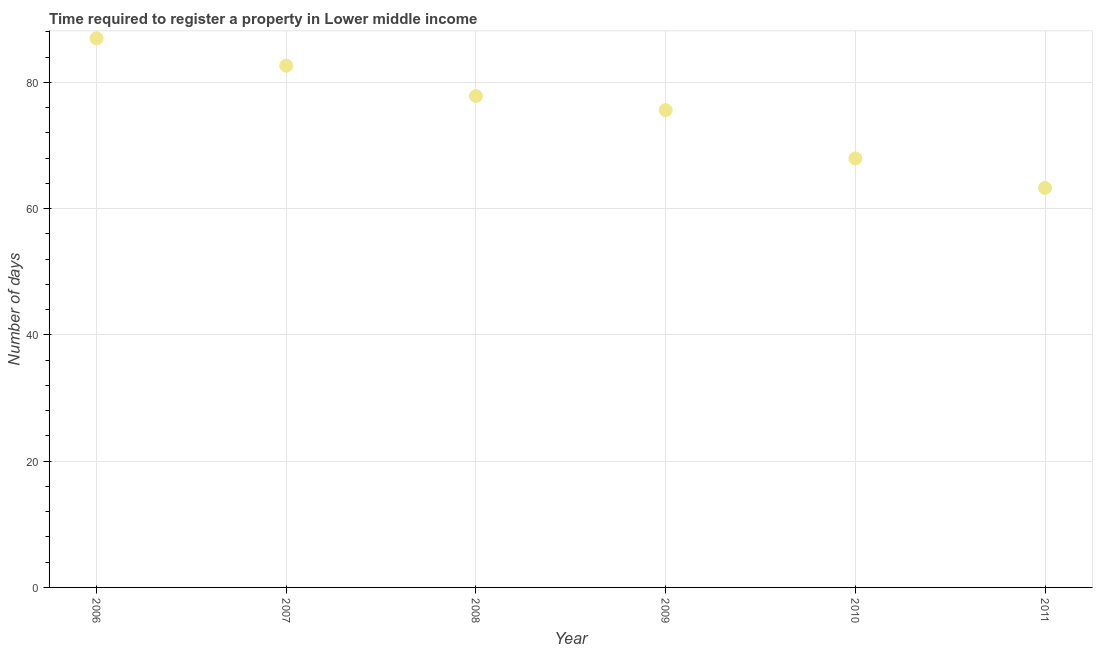What is the number of days required to register property in 2006?
Your answer should be compact. 86.96. Across all years, what is the maximum number of days required to register property?
Offer a terse response. 86.96. Across all years, what is the minimum number of days required to register property?
Offer a very short reply. 63.27. In which year was the number of days required to register property minimum?
Your answer should be compact. 2011. What is the sum of the number of days required to register property?
Your answer should be compact. 454.22. What is the difference between the number of days required to register property in 2006 and 2009?
Offer a very short reply. 11.37. What is the average number of days required to register property per year?
Your response must be concise. 75.7. What is the median number of days required to register property?
Provide a succinct answer. 76.71. In how many years, is the number of days required to register property greater than 80 days?
Your answer should be compact. 2. Do a majority of the years between 2010 and 2008 (inclusive) have number of days required to register property greater than 28 days?
Keep it short and to the point. No. What is the ratio of the number of days required to register property in 2008 to that in 2009?
Offer a very short reply. 1.03. Is the number of days required to register property in 2006 less than that in 2010?
Your answer should be compact. No. Is the difference between the number of days required to register property in 2010 and 2011 greater than the difference between any two years?
Offer a very short reply. No. What is the difference between the highest and the second highest number of days required to register property?
Provide a short and direct response. 4.33. Is the sum of the number of days required to register property in 2008 and 2011 greater than the maximum number of days required to register property across all years?
Your response must be concise. Yes. What is the difference between the highest and the lowest number of days required to register property?
Offer a very short reply. 23.7. How many dotlines are there?
Ensure brevity in your answer.  1. What is the difference between two consecutive major ticks on the Y-axis?
Provide a short and direct response. 20. What is the title of the graph?
Provide a short and direct response. Time required to register a property in Lower middle income. What is the label or title of the Y-axis?
Make the answer very short. Number of days. What is the Number of days in 2006?
Your response must be concise. 86.96. What is the Number of days in 2007?
Your answer should be compact. 82.63. What is the Number of days in 2008?
Your response must be concise. 77.82. What is the Number of days in 2009?
Offer a terse response. 75.59. What is the Number of days in 2010?
Your response must be concise. 67.94. What is the Number of days in 2011?
Make the answer very short. 63.27. What is the difference between the Number of days in 2006 and 2007?
Give a very brief answer. 4.33. What is the difference between the Number of days in 2006 and 2008?
Ensure brevity in your answer.  9.14. What is the difference between the Number of days in 2006 and 2009?
Ensure brevity in your answer.  11.37. What is the difference between the Number of days in 2006 and 2010?
Offer a terse response. 19.02. What is the difference between the Number of days in 2006 and 2011?
Keep it short and to the point. 23.7. What is the difference between the Number of days in 2007 and 2008?
Offer a very short reply. 4.81. What is the difference between the Number of days in 2007 and 2009?
Your response must be concise. 7.04. What is the difference between the Number of days in 2007 and 2010?
Offer a terse response. 14.69. What is the difference between the Number of days in 2007 and 2011?
Offer a very short reply. 19.36. What is the difference between the Number of days in 2008 and 2009?
Make the answer very short. 2.23. What is the difference between the Number of days in 2008 and 2010?
Your answer should be very brief. 9.88. What is the difference between the Number of days in 2008 and 2011?
Provide a short and direct response. 14.55. What is the difference between the Number of days in 2009 and 2010?
Your answer should be very brief. 7.65. What is the difference between the Number of days in 2009 and 2011?
Offer a very short reply. 12.33. What is the difference between the Number of days in 2010 and 2011?
Offer a very short reply. 4.67. What is the ratio of the Number of days in 2006 to that in 2007?
Offer a terse response. 1.05. What is the ratio of the Number of days in 2006 to that in 2008?
Your answer should be compact. 1.12. What is the ratio of the Number of days in 2006 to that in 2009?
Your response must be concise. 1.15. What is the ratio of the Number of days in 2006 to that in 2010?
Ensure brevity in your answer.  1.28. What is the ratio of the Number of days in 2006 to that in 2011?
Offer a terse response. 1.38. What is the ratio of the Number of days in 2007 to that in 2008?
Offer a terse response. 1.06. What is the ratio of the Number of days in 2007 to that in 2009?
Offer a terse response. 1.09. What is the ratio of the Number of days in 2007 to that in 2010?
Make the answer very short. 1.22. What is the ratio of the Number of days in 2007 to that in 2011?
Provide a succinct answer. 1.31. What is the ratio of the Number of days in 2008 to that in 2010?
Make the answer very short. 1.15. What is the ratio of the Number of days in 2008 to that in 2011?
Provide a short and direct response. 1.23. What is the ratio of the Number of days in 2009 to that in 2010?
Make the answer very short. 1.11. What is the ratio of the Number of days in 2009 to that in 2011?
Your response must be concise. 1.2. What is the ratio of the Number of days in 2010 to that in 2011?
Offer a very short reply. 1.07. 